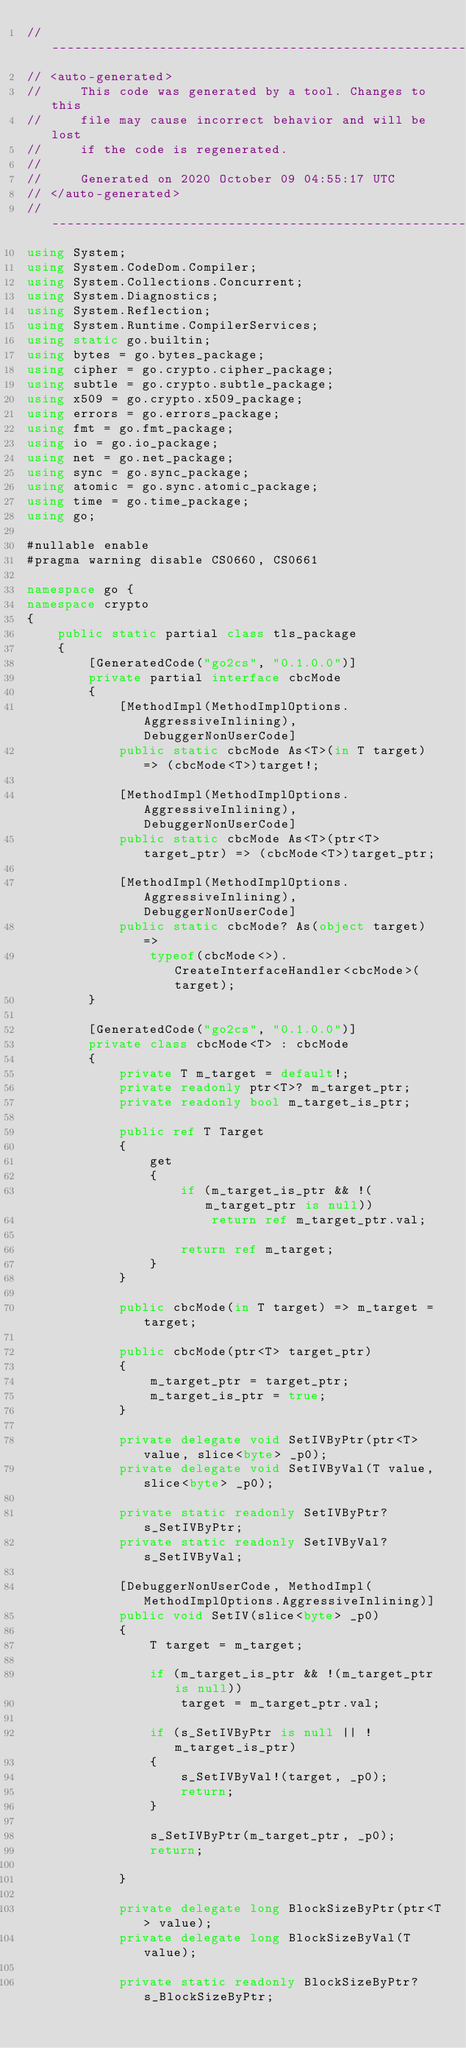Convert code to text. <code><loc_0><loc_0><loc_500><loc_500><_C#_>//---------------------------------------------------------
// <auto-generated>
//     This code was generated by a tool. Changes to this
//     file may cause incorrect behavior and will be lost
//     if the code is regenerated.
//
//     Generated on 2020 October 09 04:55:17 UTC
// </auto-generated>
//---------------------------------------------------------
using System;
using System.CodeDom.Compiler;
using System.Collections.Concurrent;
using System.Diagnostics;
using System.Reflection;
using System.Runtime.CompilerServices;
using static go.builtin;
using bytes = go.bytes_package;
using cipher = go.crypto.cipher_package;
using subtle = go.crypto.subtle_package;
using x509 = go.crypto.x509_package;
using errors = go.errors_package;
using fmt = go.fmt_package;
using io = go.io_package;
using net = go.net_package;
using sync = go.sync_package;
using atomic = go.sync.atomic_package;
using time = go.time_package;
using go;

#nullable enable
#pragma warning disable CS0660, CS0661

namespace go {
namespace crypto
{
    public static partial class tls_package
    {
        [GeneratedCode("go2cs", "0.1.0.0")]
        private partial interface cbcMode
        {
            [MethodImpl(MethodImplOptions.AggressiveInlining), DebuggerNonUserCode]
            public static cbcMode As<T>(in T target) => (cbcMode<T>)target!;

            [MethodImpl(MethodImplOptions.AggressiveInlining), DebuggerNonUserCode]
            public static cbcMode As<T>(ptr<T> target_ptr) => (cbcMode<T>)target_ptr;

            [MethodImpl(MethodImplOptions.AggressiveInlining), DebuggerNonUserCode]
            public static cbcMode? As(object target) =>
                typeof(cbcMode<>).CreateInterfaceHandler<cbcMode>(target);
        }

        [GeneratedCode("go2cs", "0.1.0.0")]
        private class cbcMode<T> : cbcMode
        {
            private T m_target = default!;
            private readonly ptr<T>? m_target_ptr;
            private readonly bool m_target_is_ptr;

            public ref T Target
            {
                get
                {
                    if (m_target_is_ptr && !(m_target_ptr is null))
                        return ref m_target_ptr.val;

                    return ref m_target;
                }
            }

            public cbcMode(in T target) => m_target = target;

            public cbcMode(ptr<T> target_ptr)
            {
                m_target_ptr = target_ptr;
                m_target_is_ptr = true;
            }

            private delegate void SetIVByPtr(ptr<T> value, slice<byte> _p0);
            private delegate void SetIVByVal(T value, slice<byte> _p0);

            private static readonly SetIVByPtr? s_SetIVByPtr;
            private static readonly SetIVByVal? s_SetIVByVal;

            [DebuggerNonUserCode, MethodImpl(MethodImplOptions.AggressiveInlining)]
            public void SetIV(slice<byte> _p0)
            {
                T target = m_target;

                if (m_target_is_ptr && !(m_target_ptr is null))
                    target = m_target_ptr.val;

                if (s_SetIVByPtr is null || !m_target_is_ptr)
                {
                    s_SetIVByVal!(target, _p0);
                    return;
                }

                s_SetIVByPtr(m_target_ptr, _p0);
                return;
                
            }

            private delegate long BlockSizeByPtr(ptr<T> value);
            private delegate long BlockSizeByVal(T value);

            private static readonly BlockSizeByPtr? s_BlockSizeByPtr;</code> 